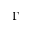<formula> <loc_0><loc_0><loc_500><loc_500>\Gamma</formula> 